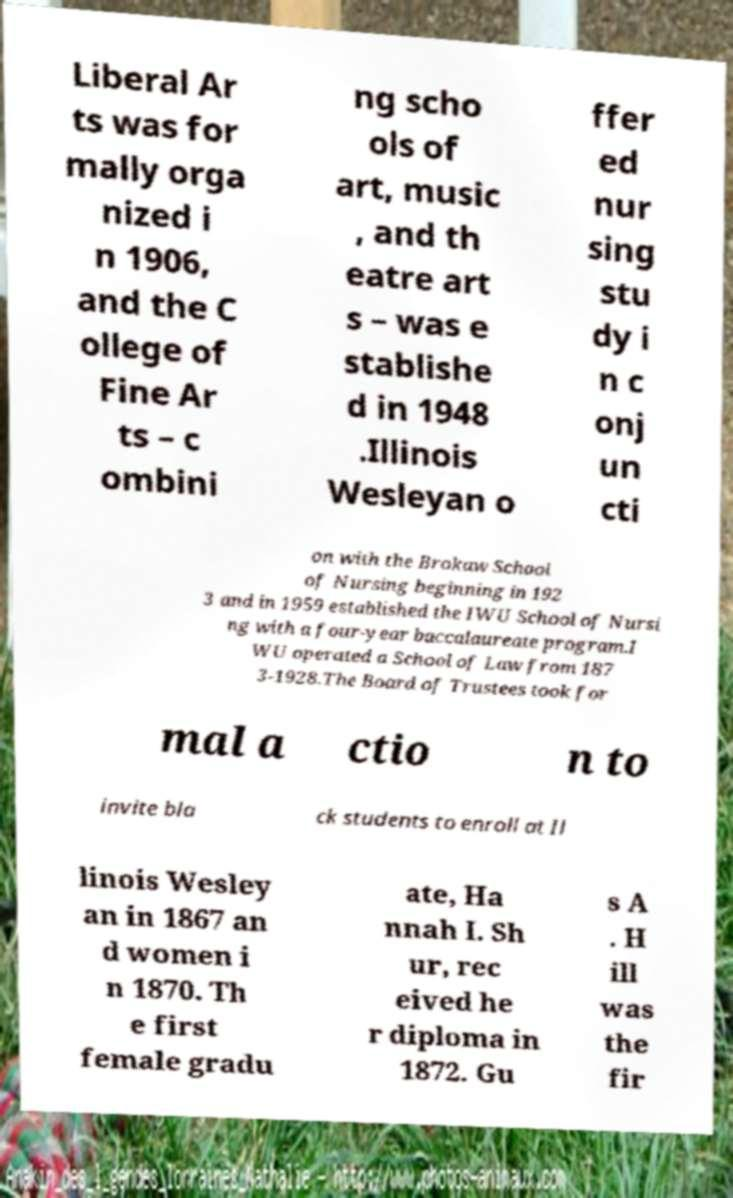Can you read and provide the text displayed in the image?This photo seems to have some interesting text. Can you extract and type it out for me? Liberal Ar ts was for mally orga nized i n 1906, and the C ollege of Fine Ar ts – c ombini ng scho ols of art, music , and th eatre art s – was e stablishe d in 1948 .Illinois Wesleyan o ffer ed nur sing stu dy i n c onj un cti on with the Brokaw School of Nursing beginning in 192 3 and in 1959 established the IWU School of Nursi ng with a four-year baccalaureate program.I WU operated a School of Law from 187 3-1928.The Board of Trustees took for mal a ctio n to invite bla ck students to enroll at Il linois Wesley an in 1867 an d women i n 1870. Th e first female gradu ate, Ha nnah I. Sh ur, rec eived he r diploma in 1872. Gu s A . H ill was the fir 